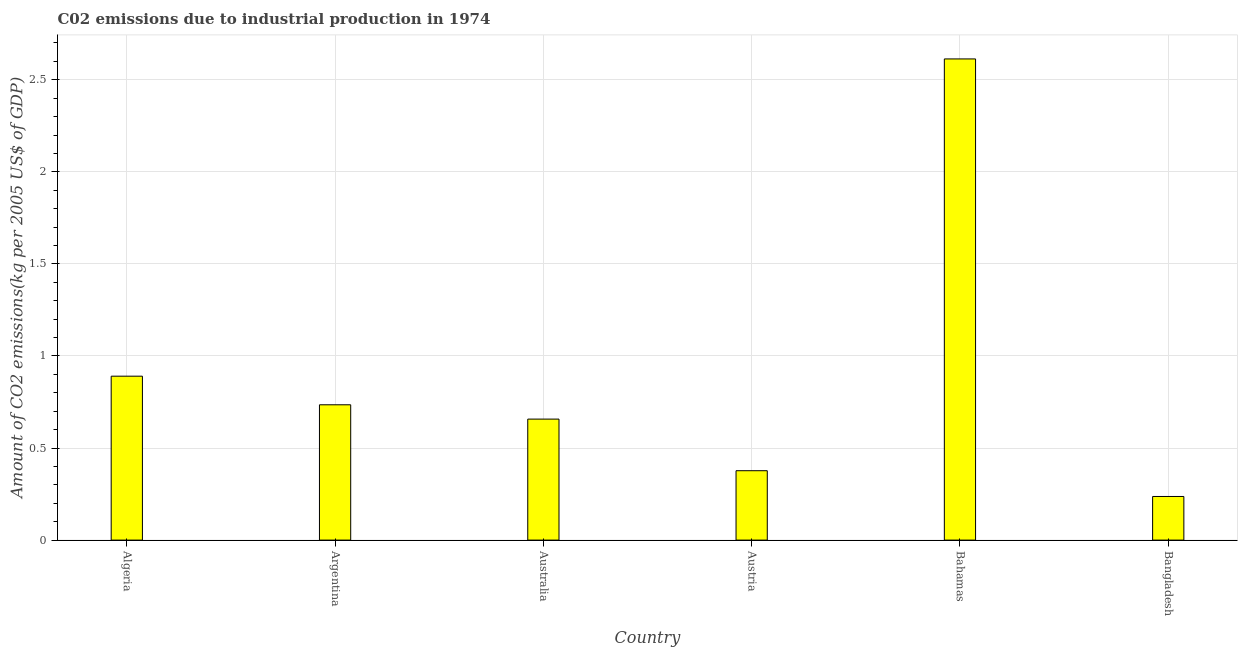Does the graph contain grids?
Provide a short and direct response. Yes. What is the title of the graph?
Provide a succinct answer. C02 emissions due to industrial production in 1974. What is the label or title of the X-axis?
Your response must be concise. Country. What is the label or title of the Y-axis?
Your answer should be very brief. Amount of CO2 emissions(kg per 2005 US$ of GDP). What is the amount of co2 emissions in Algeria?
Provide a succinct answer. 0.89. Across all countries, what is the maximum amount of co2 emissions?
Your answer should be compact. 2.61. Across all countries, what is the minimum amount of co2 emissions?
Your response must be concise. 0.24. In which country was the amount of co2 emissions maximum?
Offer a very short reply. Bahamas. What is the sum of the amount of co2 emissions?
Ensure brevity in your answer.  5.51. What is the difference between the amount of co2 emissions in Australia and Bahamas?
Offer a very short reply. -1.96. What is the average amount of co2 emissions per country?
Your answer should be compact. 0.92. What is the median amount of co2 emissions?
Give a very brief answer. 0.7. What is the ratio of the amount of co2 emissions in Australia to that in Bahamas?
Provide a short and direct response. 0.25. Is the difference between the amount of co2 emissions in Argentina and Austria greater than the difference between any two countries?
Offer a terse response. No. What is the difference between the highest and the second highest amount of co2 emissions?
Keep it short and to the point. 1.72. What is the difference between the highest and the lowest amount of co2 emissions?
Give a very brief answer. 2.38. In how many countries, is the amount of co2 emissions greater than the average amount of co2 emissions taken over all countries?
Your answer should be compact. 1. Are the values on the major ticks of Y-axis written in scientific E-notation?
Provide a short and direct response. No. What is the Amount of CO2 emissions(kg per 2005 US$ of GDP) in Algeria?
Offer a terse response. 0.89. What is the Amount of CO2 emissions(kg per 2005 US$ of GDP) in Argentina?
Provide a short and direct response. 0.73. What is the Amount of CO2 emissions(kg per 2005 US$ of GDP) in Australia?
Provide a short and direct response. 0.66. What is the Amount of CO2 emissions(kg per 2005 US$ of GDP) in Austria?
Your response must be concise. 0.38. What is the Amount of CO2 emissions(kg per 2005 US$ of GDP) in Bahamas?
Make the answer very short. 2.61. What is the Amount of CO2 emissions(kg per 2005 US$ of GDP) of Bangladesh?
Your response must be concise. 0.24. What is the difference between the Amount of CO2 emissions(kg per 2005 US$ of GDP) in Algeria and Argentina?
Ensure brevity in your answer.  0.16. What is the difference between the Amount of CO2 emissions(kg per 2005 US$ of GDP) in Algeria and Australia?
Make the answer very short. 0.23. What is the difference between the Amount of CO2 emissions(kg per 2005 US$ of GDP) in Algeria and Austria?
Provide a short and direct response. 0.51. What is the difference between the Amount of CO2 emissions(kg per 2005 US$ of GDP) in Algeria and Bahamas?
Keep it short and to the point. -1.72. What is the difference between the Amount of CO2 emissions(kg per 2005 US$ of GDP) in Algeria and Bangladesh?
Your answer should be compact. 0.65. What is the difference between the Amount of CO2 emissions(kg per 2005 US$ of GDP) in Argentina and Australia?
Provide a succinct answer. 0.08. What is the difference between the Amount of CO2 emissions(kg per 2005 US$ of GDP) in Argentina and Austria?
Provide a short and direct response. 0.36. What is the difference between the Amount of CO2 emissions(kg per 2005 US$ of GDP) in Argentina and Bahamas?
Your answer should be compact. -1.88. What is the difference between the Amount of CO2 emissions(kg per 2005 US$ of GDP) in Argentina and Bangladesh?
Offer a terse response. 0.5. What is the difference between the Amount of CO2 emissions(kg per 2005 US$ of GDP) in Australia and Austria?
Your answer should be very brief. 0.28. What is the difference between the Amount of CO2 emissions(kg per 2005 US$ of GDP) in Australia and Bahamas?
Your response must be concise. -1.96. What is the difference between the Amount of CO2 emissions(kg per 2005 US$ of GDP) in Australia and Bangladesh?
Make the answer very short. 0.42. What is the difference between the Amount of CO2 emissions(kg per 2005 US$ of GDP) in Austria and Bahamas?
Your answer should be very brief. -2.24. What is the difference between the Amount of CO2 emissions(kg per 2005 US$ of GDP) in Austria and Bangladesh?
Ensure brevity in your answer.  0.14. What is the difference between the Amount of CO2 emissions(kg per 2005 US$ of GDP) in Bahamas and Bangladesh?
Your answer should be compact. 2.38. What is the ratio of the Amount of CO2 emissions(kg per 2005 US$ of GDP) in Algeria to that in Argentina?
Offer a very short reply. 1.21. What is the ratio of the Amount of CO2 emissions(kg per 2005 US$ of GDP) in Algeria to that in Australia?
Provide a succinct answer. 1.35. What is the ratio of the Amount of CO2 emissions(kg per 2005 US$ of GDP) in Algeria to that in Austria?
Make the answer very short. 2.36. What is the ratio of the Amount of CO2 emissions(kg per 2005 US$ of GDP) in Algeria to that in Bahamas?
Your response must be concise. 0.34. What is the ratio of the Amount of CO2 emissions(kg per 2005 US$ of GDP) in Algeria to that in Bangladesh?
Provide a succinct answer. 3.76. What is the ratio of the Amount of CO2 emissions(kg per 2005 US$ of GDP) in Argentina to that in Australia?
Your response must be concise. 1.12. What is the ratio of the Amount of CO2 emissions(kg per 2005 US$ of GDP) in Argentina to that in Austria?
Keep it short and to the point. 1.95. What is the ratio of the Amount of CO2 emissions(kg per 2005 US$ of GDP) in Argentina to that in Bahamas?
Provide a short and direct response. 0.28. What is the ratio of the Amount of CO2 emissions(kg per 2005 US$ of GDP) in Argentina to that in Bangladesh?
Give a very brief answer. 3.1. What is the ratio of the Amount of CO2 emissions(kg per 2005 US$ of GDP) in Australia to that in Austria?
Keep it short and to the point. 1.74. What is the ratio of the Amount of CO2 emissions(kg per 2005 US$ of GDP) in Australia to that in Bahamas?
Give a very brief answer. 0.25. What is the ratio of the Amount of CO2 emissions(kg per 2005 US$ of GDP) in Australia to that in Bangladesh?
Give a very brief answer. 2.77. What is the ratio of the Amount of CO2 emissions(kg per 2005 US$ of GDP) in Austria to that in Bahamas?
Make the answer very short. 0.14. What is the ratio of the Amount of CO2 emissions(kg per 2005 US$ of GDP) in Austria to that in Bangladesh?
Offer a terse response. 1.59. What is the ratio of the Amount of CO2 emissions(kg per 2005 US$ of GDP) in Bahamas to that in Bangladesh?
Make the answer very short. 11.03. 